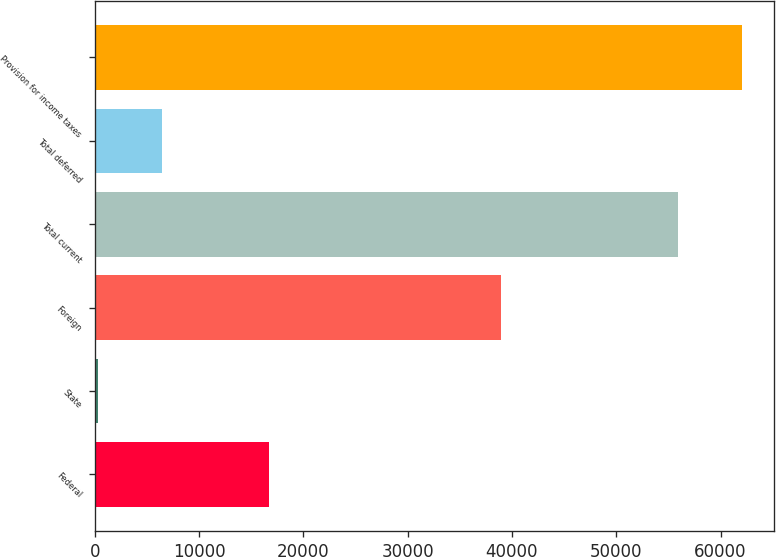Convert chart. <chart><loc_0><loc_0><loc_500><loc_500><bar_chart><fcel>Federal<fcel>State<fcel>Foreign<fcel>Total current<fcel>Total deferred<fcel>Provision for income taxes<nl><fcel>16675<fcel>309<fcel>38941<fcel>55925<fcel>6425.2<fcel>62041.2<nl></chart> 